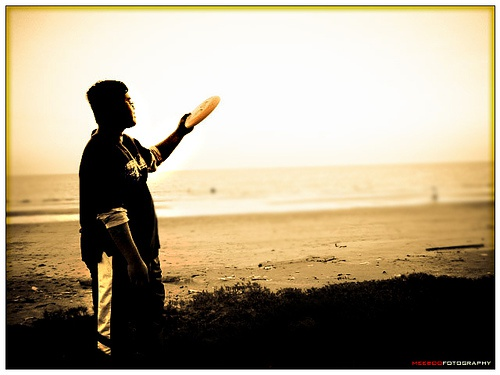Describe the objects in this image and their specific colors. I can see people in white, black, gold, orange, and maroon tones and frisbee in white, khaki, orange, gold, and ivory tones in this image. 